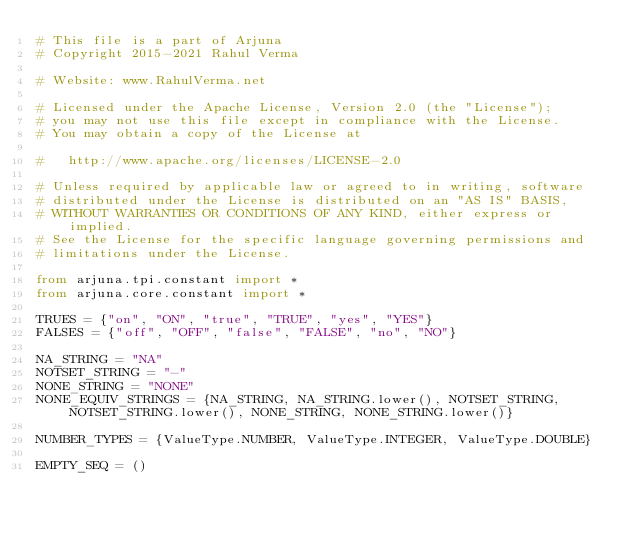Convert code to text. <code><loc_0><loc_0><loc_500><loc_500><_Python_># This file is a part of Arjuna
# Copyright 2015-2021 Rahul Verma

# Website: www.RahulVerma.net

# Licensed under the Apache License, Version 2.0 (the "License");
# you may not use this file except in compliance with the License.
# You may obtain a copy of the License at

#   http://www.apache.org/licenses/LICENSE-2.0

# Unless required by applicable law or agreed to in writing, software
# distributed under the License is distributed on an "AS IS" BASIS,
# WITHOUT WARRANTIES OR CONDITIONS OF ANY KIND, either express or implied.
# See the License for the specific language governing permissions and
# limitations under the License.

from arjuna.tpi.constant import *
from arjuna.core.constant import *

TRUES = {"on", "ON", "true", "TRUE", "yes", "YES"}
FALSES = {"off", "OFF", "false", "FALSE", "no", "NO"}

NA_STRING = "NA"
NOTSET_STRING = "-"
NONE_STRING = "NONE"
NONE_EQUIV_STRINGS = {NA_STRING, NA_STRING.lower(), NOTSET_STRING, NOTSET_STRING.lower(), NONE_STRING, NONE_STRING.lower()}

NUMBER_TYPES = {ValueType.NUMBER, ValueType.INTEGER, ValueType.DOUBLE}

EMPTY_SEQ = ()
</code> 